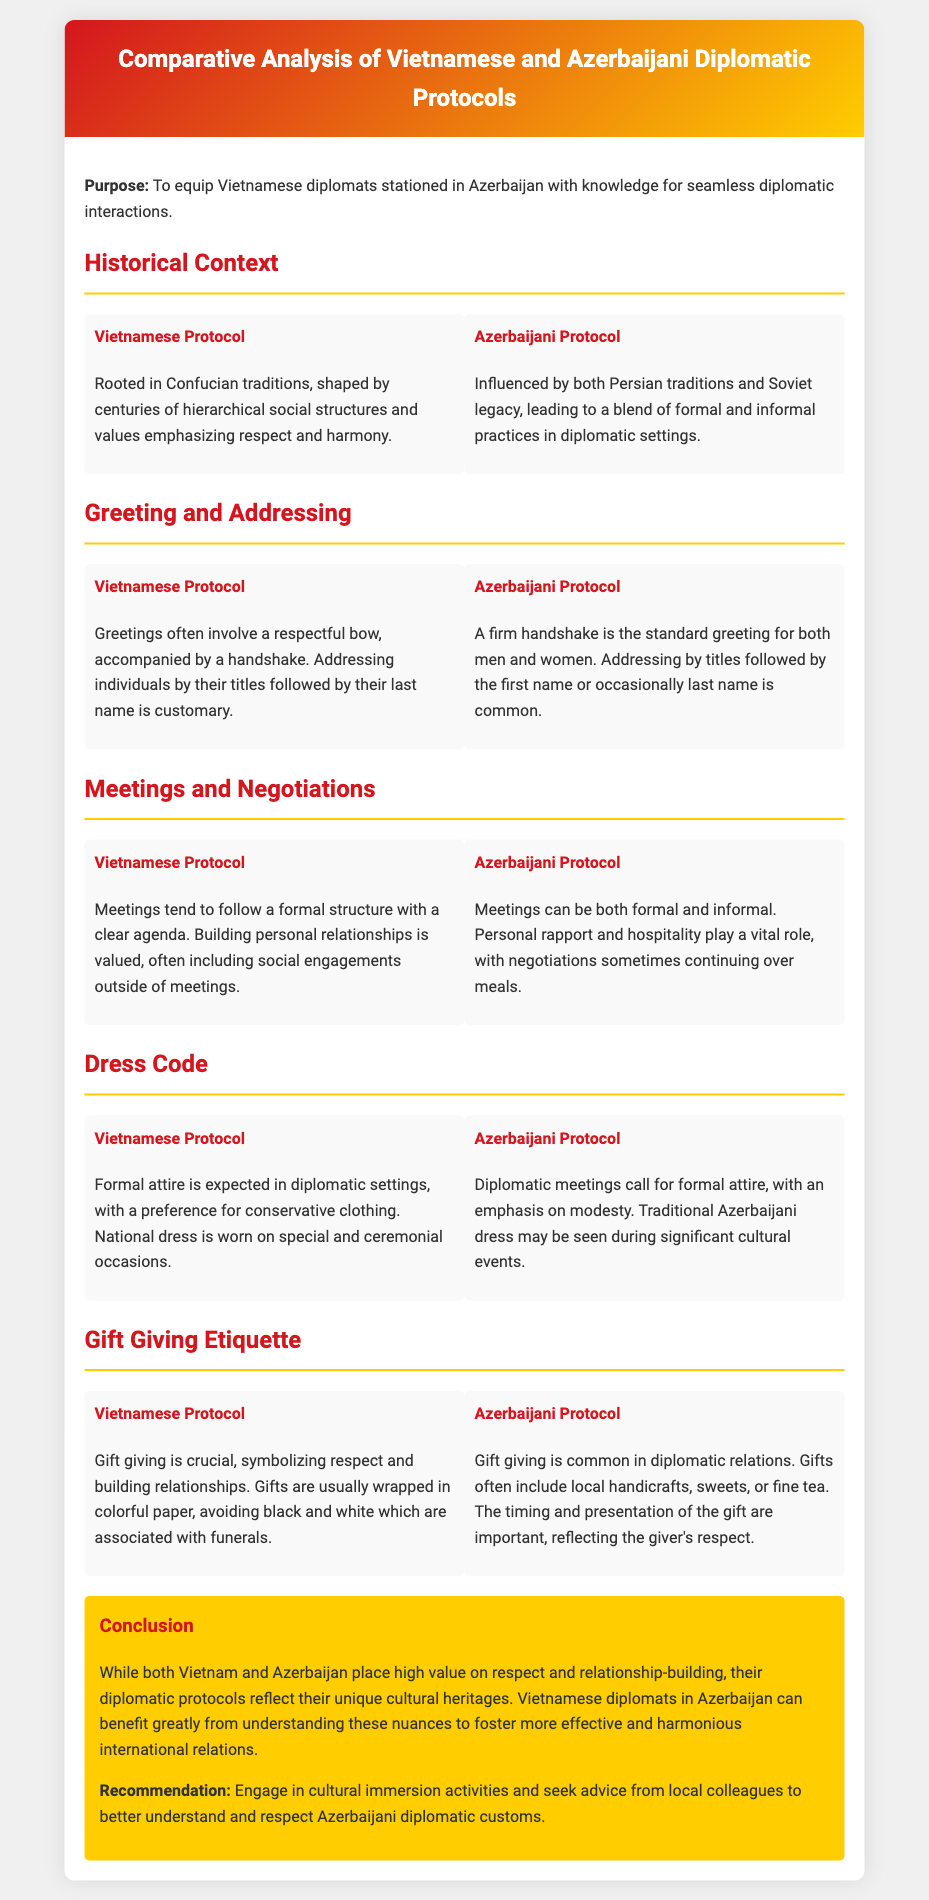What is the title of the document? The title of the document is found in the header section, clearly displayed at the top.
Answer: Comparative Analysis of Vietnamese and Azerbaijani Diplomatic Protocols What is the main purpose of the document? The purpose is stated at the beginning of the content, outlining the document's aim.
Answer: To equip Vietnamese diplomats stationed in Azerbaijan with knowledge for seamless diplomatic interactions What cultural tradition influences Vietnamese diplomatic protocol? The document mentions specific cultural traditions that shape Vietnamese protocol in the historical context section.
Answer: Confucian traditions How do Vietnamese diplomats greet others? The greeting method for Vietnamese diplomats is described under the Greeting and Addressing section.
Answer: A respectful bow, accompanied by a handshake What is a key aspect of Azerbaijani meetings? The document describes the nature of meetings in the context of Azerbaijani protocol.
Answer: Personal rapport and hospitality Which colors should be avoided when wrapping gifts in Vietnam? The document specifically lists colors associated with funerals that are to be avoided in gift-giving.
Answer: Black and white What should Vietnamese diplomats do to better understand Azerbaijani customs? The recommendation section suggests a specific course of action for diplomats.
Answer: Engage in cultural immersion activities What type of attire is expected in Vietnamese diplomatic settings? The dress code for Vietnamese diplomats is stated in the corresponding section.
Answer: Formal attire In the conclusion, what two concepts are emphasized for both countries? The conclusion highlights significant values for both countries discussed throughout the document.
Answer: Respect and relationship-building 